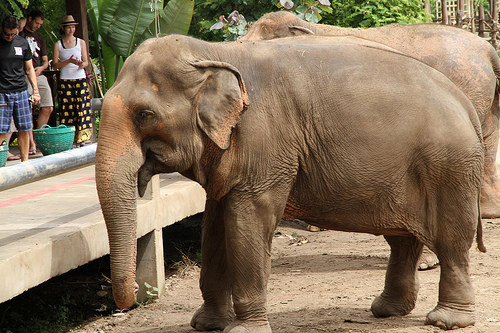Are there any small monkeys or elephants? No, there are no small monkeys or elephants visible in the image. 